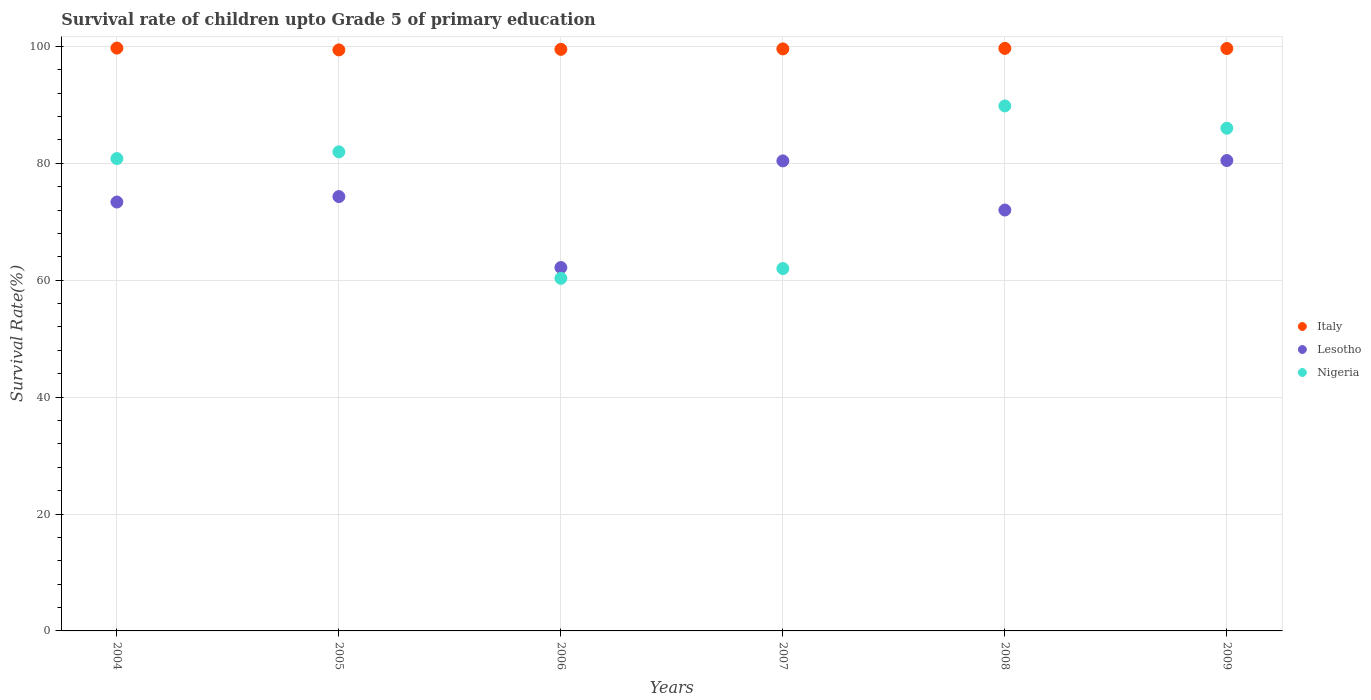Is the number of dotlines equal to the number of legend labels?
Your answer should be compact. Yes. What is the survival rate of children in Nigeria in 2008?
Your response must be concise. 89.82. Across all years, what is the maximum survival rate of children in Italy?
Offer a very short reply. 99.71. Across all years, what is the minimum survival rate of children in Lesotho?
Your answer should be compact. 62.17. In which year was the survival rate of children in Nigeria maximum?
Offer a terse response. 2008. What is the total survival rate of children in Nigeria in the graph?
Your response must be concise. 460.9. What is the difference between the survival rate of children in Italy in 2006 and that in 2009?
Your answer should be compact. -0.14. What is the difference between the survival rate of children in Italy in 2006 and the survival rate of children in Lesotho in 2009?
Your answer should be very brief. 19.02. What is the average survival rate of children in Italy per year?
Offer a very short reply. 99.58. In the year 2005, what is the difference between the survival rate of children in Nigeria and survival rate of children in Lesotho?
Your answer should be compact. 7.65. What is the ratio of the survival rate of children in Lesotho in 2007 to that in 2008?
Your answer should be compact. 1.12. What is the difference between the highest and the second highest survival rate of children in Italy?
Your answer should be very brief. 0.05. What is the difference between the highest and the lowest survival rate of children in Lesotho?
Provide a short and direct response. 18.31. Is the sum of the survival rate of children in Lesotho in 2007 and 2009 greater than the maximum survival rate of children in Nigeria across all years?
Make the answer very short. Yes. Is it the case that in every year, the sum of the survival rate of children in Lesotho and survival rate of children in Nigeria  is greater than the survival rate of children in Italy?
Give a very brief answer. Yes. Is the survival rate of children in Lesotho strictly greater than the survival rate of children in Nigeria over the years?
Your response must be concise. No. Is the survival rate of children in Italy strictly less than the survival rate of children in Lesotho over the years?
Your answer should be compact. No. What is the difference between two consecutive major ticks on the Y-axis?
Make the answer very short. 20. What is the title of the graph?
Give a very brief answer. Survival rate of children upto Grade 5 of primary education. What is the label or title of the X-axis?
Provide a short and direct response. Years. What is the label or title of the Y-axis?
Make the answer very short. Survival Rate(%). What is the Survival Rate(%) of Italy in 2004?
Make the answer very short. 99.71. What is the Survival Rate(%) of Lesotho in 2004?
Give a very brief answer. 73.37. What is the Survival Rate(%) of Nigeria in 2004?
Make the answer very short. 80.81. What is the Survival Rate(%) of Italy in 2005?
Your answer should be compact. 99.4. What is the Survival Rate(%) in Lesotho in 2005?
Your response must be concise. 74.31. What is the Survival Rate(%) of Nigeria in 2005?
Give a very brief answer. 81.96. What is the Survival Rate(%) in Italy in 2006?
Ensure brevity in your answer.  99.5. What is the Survival Rate(%) of Lesotho in 2006?
Provide a short and direct response. 62.17. What is the Survival Rate(%) of Nigeria in 2006?
Your response must be concise. 60.32. What is the Survival Rate(%) of Italy in 2007?
Make the answer very short. 99.57. What is the Survival Rate(%) in Lesotho in 2007?
Give a very brief answer. 80.41. What is the Survival Rate(%) of Nigeria in 2007?
Keep it short and to the point. 61.99. What is the Survival Rate(%) in Italy in 2008?
Give a very brief answer. 99.66. What is the Survival Rate(%) in Lesotho in 2008?
Offer a terse response. 72. What is the Survival Rate(%) in Nigeria in 2008?
Offer a terse response. 89.82. What is the Survival Rate(%) of Italy in 2009?
Give a very brief answer. 99.64. What is the Survival Rate(%) of Lesotho in 2009?
Give a very brief answer. 80.48. What is the Survival Rate(%) in Nigeria in 2009?
Ensure brevity in your answer.  86. Across all years, what is the maximum Survival Rate(%) of Italy?
Ensure brevity in your answer.  99.71. Across all years, what is the maximum Survival Rate(%) in Lesotho?
Your answer should be compact. 80.48. Across all years, what is the maximum Survival Rate(%) in Nigeria?
Offer a terse response. 89.82. Across all years, what is the minimum Survival Rate(%) in Italy?
Keep it short and to the point. 99.4. Across all years, what is the minimum Survival Rate(%) of Lesotho?
Make the answer very short. 62.17. Across all years, what is the minimum Survival Rate(%) in Nigeria?
Provide a short and direct response. 60.32. What is the total Survival Rate(%) of Italy in the graph?
Provide a short and direct response. 597.49. What is the total Survival Rate(%) in Lesotho in the graph?
Give a very brief answer. 442.74. What is the total Survival Rate(%) in Nigeria in the graph?
Ensure brevity in your answer.  460.9. What is the difference between the Survival Rate(%) in Italy in 2004 and that in 2005?
Keep it short and to the point. 0.31. What is the difference between the Survival Rate(%) of Lesotho in 2004 and that in 2005?
Keep it short and to the point. -0.94. What is the difference between the Survival Rate(%) in Nigeria in 2004 and that in 2005?
Offer a very short reply. -1.15. What is the difference between the Survival Rate(%) of Italy in 2004 and that in 2006?
Provide a succinct answer. 0.21. What is the difference between the Survival Rate(%) of Lesotho in 2004 and that in 2006?
Provide a short and direct response. 11.21. What is the difference between the Survival Rate(%) in Nigeria in 2004 and that in 2006?
Give a very brief answer. 20.49. What is the difference between the Survival Rate(%) of Italy in 2004 and that in 2007?
Keep it short and to the point. 0.14. What is the difference between the Survival Rate(%) in Lesotho in 2004 and that in 2007?
Ensure brevity in your answer.  -7.04. What is the difference between the Survival Rate(%) of Nigeria in 2004 and that in 2007?
Offer a very short reply. 18.82. What is the difference between the Survival Rate(%) in Italy in 2004 and that in 2008?
Your response must be concise. 0.05. What is the difference between the Survival Rate(%) in Lesotho in 2004 and that in 2008?
Your response must be concise. 1.37. What is the difference between the Survival Rate(%) in Nigeria in 2004 and that in 2008?
Provide a succinct answer. -9. What is the difference between the Survival Rate(%) in Italy in 2004 and that in 2009?
Offer a terse response. 0.07. What is the difference between the Survival Rate(%) of Lesotho in 2004 and that in 2009?
Your answer should be compact. -7.1. What is the difference between the Survival Rate(%) in Nigeria in 2004 and that in 2009?
Make the answer very short. -5.19. What is the difference between the Survival Rate(%) in Italy in 2005 and that in 2006?
Provide a short and direct response. -0.1. What is the difference between the Survival Rate(%) in Lesotho in 2005 and that in 2006?
Provide a short and direct response. 12.14. What is the difference between the Survival Rate(%) in Nigeria in 2005 and that in 2006?
Offer a very short reply. 21.64. What is the difference between the Survival Rate(%) of Italy in 2005 and that in 2007?
Make the answer very short. -0.17. What is the difference between the Survival Rate(%) of Lesotho in 2005 and that in 2007?
Provide a succinct answer. -6.1. What is the difference between the Survival Rate(%) in Nigeria in 2005 and that in 2007?
Provide a short and direct response. 19.97. What is the difference between the Survival Rate(%) of Italy in 2005 and that in 2008?
Offer a very short reply. -0.26. What is the difference between the Survival Rate(%) of Lesotho in 2005 and that in 2008?
Offer a very short reply. 2.31. What is the difference between the Survival Rate(%) of Nigeria in 2005 and that in 2008?
Make the answer very short. -7.85. What is the difference between the Survival Rate(%) of Italy in 2005 and that in 2009?
Provide a short and direct response. -0.24. What is the difference between the Survival Rate(%) of Lesotho in 2005 and that in 2009?
Give a very brief answer. -6.17. What is the difference between the Survival Rate(%) in Nigeria in 2005 and that in 2009?
Give a very brief answer. -4.04. What is the difference between the Survival Rate(%) in Italy in 2006 and that in 2007?
Ensure brevity in your answer.  -0.08. What is the difference between the Survival Rate(%) in Lesotho in 2006 and that in 2007?
Ensure brevity in your answer.  -18.24. What is the difference between the Survival Rate(%) of Nigeria in 2006 and that in 2007?
Offer a very short reply. -1.67. What is the difference between the Survival Rate(%) in Italy in 2006 and that in 2008?
Offer a very short reply. -0.16. What is the difference between the Survival Rate(%) of Lesotho in 2006 and that in 2008?
Give a very brief answer. -9.84. What is the difference between the Survival Rate(%) of Nigeria in 2006 and that in 2008?
Keep it short and to the point. -29.49. What is the difference between the Survival Rate(%) in Italy in 2006 and that in 2009?
Provide a succinct answer. -0.14. What is the difference between the Survival Rate(%) in Lesotho in 2006 and that in 2009?
Give a very brief answer. -18.31. What is the difference between the Survival Rate(%) in Nigeria in 2006 and that in 2009?
Give a very brief answer. -25.68. What is the difference between the Survival Rate(%) of Italy in 2007 and that in 2008?
Your answer should be compact. -0.09. What is the difference between the Survival Rate(%) in Lesotho in 2007 and that in 2008?
Provide a short and direct response. 8.41. What is the difference between the Survival Rate(%) in Nigeria in 2007 and that in 2008?
Provide a succinct answer. -27.82. What is the difference between the Survival Rate(%) in Italy in 2007 and that in 2009?
Your response must be concise. -0.07. What is the difference between the Survival Rate(%) in Lesotho in 2007 and that in 2009?
Your answer should be very brief. -0.07. What is the difference between the Survival Rate(%) of Nigeria in 2007 and that in 2009?
Provide a succinct answer. -24.01. What is the difference between the Survival Rate(%) in Italy in 2008 and that in 2009?
Your response must be concise. 0.02. What is the difference between the Survival Rate(%) in Lesotho in 2008 and that in 2009?
Provide a succinct answer. -8.47. What is the difference between the Survival Rate(%) in Nigeria in 2008 and that in 2009?
Make the answer very short. 3.81. What is the difference between the Survival Rate(%) of Italy in 2004 and the Survival Rate(%) of Lesotho in 2005?
Offer a very short reply. 25.4. What is the difference between the Survival Rate(%) of Italy in 2004 and the Survival Rate(%) of Nigeria in 2005?
Make the answer very short. 17.75. What is the difference between the Survival Rate(%) of Lesotho in 2004 and the Survival Rate(%) of Nigeria in 2005?
Offer a very short reply. -8.59. What is the difference between the Survival Rate(%) in Italy in 2004 and the Survival Rate(%) in Lesotho in 2006?
Provide a short and direct response. 37.54. What is the difference between the Survival Rate(%) of Italy in 2004 and the Survival Rate(%) of Nigeria in 2006?
Keep it short and to the point. 39.39. What is the difference between the Survival Rate(%) in Lesotho in 2004 and the Survival Rate(%) in Nigeria in 2006?
Provide a short and direct response. 13.05. What is the difference between the Survival Rate(%) in Italy in 2004 and the Survival Rate(%) in Lesotho in 2007?
Make the answer very short. 19.3. What is the difference between the Survival Rate(%) in Italy in 2004 and the Survival Rate(%) in Nigeria in 2007?
Provide a short and direct response. 37.72. What is the difference between the Survival Rate(%) of Lesotho in 2004 and the Survival Rate(%) of Nigeria in 2007?
Offer a terse response. 11.38. What is the difference between the Survival Rate(%) in Italy in 2004 and the Survival Rate(%) in Lesotho in 2008?
Your answer should be very brief. 27.71. What is the difference between the Survival Rate(%) of Italy in 2004 and the Survival Rate(%) of Nigeria in 2008?
Your answer should be compact. 9.9. What is the difference between the Survival Rate(%) of Lesotho in 2004 and the Survival Rate(%) of Nigeria in 2008?
Ensure brevity in your answer.  -16.44. What is the difference between the Survival Rate(%) in Italy in 2004 and the Survival Rate(%) in Lesotho in 2009?
Keep it short and to the point. 19.24. What is the difference between the Survival Rate(%) in Italy in 2004 and the Survival Rate(%) in Nigeria in 2009?
Your response must be concise. 13.71. What is the difference between the Survival Rate(%) in Lesotho in 2004 and the Survival Rate(%) in Nigeria in 2009?
Ensure brevity in your answer.  -12.63. What is the difference between the Survival Rate(%) in Italy in 2005 and the Survival Rate(%) in Lesotho in 2006?
Keep it short and to the point. 37.23. What is the difference between the Survival Rate(%) in Italy in 2005 and the Survival Rate(%) in Nigeria in 2006?
Offer a terse response. 39.08. What is the difference between the Survival Rate(%) of Lesotho in 2005 and the Survival Rate(%) of Nigeria in 2006?
Provide a succinct answer. 13.99. What is the difference between the Survival Rate(%) of Italy in 2005 and the Survival Rate(%) of Lesotho in 2007?
Provide a short and direct response. 18.99. What is the difference between the Survival Rate(%) in Italy in 2005 and the Survival Rate(%) in Nigeria in 2007?
Provide a succinct answer. 37.41. What is the difference between the Survival Rate(%) in Lesotho in 2005 and the Survival Rate(%) in Nigeria in 2007?
Your answer should be compact. 12.32. What is the difference between the Survival Rate(%) of Italy in 2005 and the Survival Rate(%) of Lesotho in 2008?
Your answer should be very brief. 27.4. What is the difference between the Survival Rate(%) of Italy in 2005 and the Survival Rate(%) of Nigeria in 2008?
Your answer should be compact. 9.59. What is the difference between the Survival Rate(%) of Lesotho in 2005 and the Survival Rate(%) of Nigeria in 2008?
Your response must be concise. -15.51. What is the difference between the Survival Rate(%) in Italy in 2005 and the Survival Rate(%) in Lesotho in 2009?
Keep it short and to the point. 18.92. What is the difference between the Survival Rate(%) of Italy in 2005 and the Survival Rate(%) of Nigeria in 2009?
Ensure brevity in your answer.  13.4. What is the difference between the Survival Rate(%) in Lesotho in 2005 and the Survival Rate(%) in Nigeria in 2009?
Offer a terse response. -11.69. What is the difference between the Survival Rate(%) of Italy in 2006 and the Survival Rate(%) of Lesotho in 2007?
Offer a very short reply. 19.09. What is the difference between the Survival Rate(%) of Italy in 2006 and the Survival Rate(%) of Nigeria in 2007?
Keep it short and to the point. 37.51. What is the difference between the Survival Rate(%) of Lesotho in 2006 and the Survival Rate(%) of Nigeria in 2007?
Give a very brief answer. 0.18. What is the difference between the Survival Rate(%) in Italy in 2006 and the Survival Rate(%) in Lesotho in 2008?
Your answer should be very brief. 27.49. What is the difference between the Survival Rate(%) in Italy in 2006 and the Survival Rate(%) in Nigeria in 2008?
Offer a terse response. 9.68. What is the difference between the Survival Rate(%) of Lesotho in 2006 and the Survival Rate(%) of Nigeria in 2008?
Offer a very short reply. -27.65. What is the difference between the Survival Rate(%) in Italy in 2006 and the Survival Rate(%) in Lesotho in 2009?
Make the answer very short. 19.02. What is the difference between the Survival Rate(%) in Italy in 2006 and the Survival Rate(%) in Nigeria in 2009?
Make the answer very short. 13.5. What is the difference between the Survival Rate(%) of Lesotho in 2006 and the Survival Rate(%) of Nigeria in 2009?
Give a very brief answer. -23.83. What is the difference between the Survival Rate(%) of Italy in 2007 and the Survival Rate(%) of Lesotho in 2008?
Ensure brevity in your answer.  27.57. What is the difference between the Survival Rate(%) of Italy in 2007 and the Survival Rate(%) of Nigeria in 2008?
Your response must be concise. 9.76. What is the difference between the Survival Rate(%) in Lesotho in 2007 and the Survival Rate(%) in Nigeria in 2008?
Provide a succinct answer. -9.4. What is the difference between the Survival Rate(%) in Italy in 2007 and the Survival Rate(%) in Lesotho in 2009?
Provide a succinct answer. 19.1. What is the difference between the Survival Rate(%) in Italy in 2007 and the Survival Rate(%) in Nigeria in 2009?
Your answer should be very brief. 13.57. What is the difference between the Survival Rate(%) of Lesotho in 2007 and the Survival Rate(%) of Nigeria in 2009?
Your response must be concise. -5.59. What is the difference between the Survival Rate(%) in Italy in 2008 and the Survival Rate(%) in Lesotho in 2009?
Keep it short and to the point. 19.18. What is the difference between the Survival Rate(%) in Italy in 2008 and the Survival Rate(%) in Nigeria in 2009?
Your answer should be very brief. 13.66. What is the difference between the Survival Rate(%) of Lesotho in 2008 and the Survival Rate(%) of Nigeria in 2009?
Make the answer very short. -14. What is the average Survival Rate(%) in Italy per year?
Offer a very short reply. 99.58. What is the average Survival Rate(%) of Lesotho per year?
Provide a short and direct response. 73.79. What is the average Survival Rate(%) of Nigeria per year?
Your response must be concise. 76.82. In the year 2004, what is the difference between the Survival Rate(%) in Italy and Survival Rate(%) in Lesotho?
Keep it short and to the point. 26.34. In the year 2004, what is the difference between the Survival Rate(%) in Italy and Survival Rate(%) in Nigeria?
Offer a very short reply. 18.9. In the year 2004, what is the difference between the Survival Rate(%) of Lesotho and Survival Rate(%) of Nigeria?
Give a very brief answer. -7.44. In the year 2005, what is the difference between the Survival Rate(%) in Italy and Survival Rate(%) in Lesotho?
Ensure brevity in your answer.  25.09. In the year 2005, what is the difference between the Survival Rate(%) in Italy and Survival Rate(%) in Nigeria?
Offer a terse response. 17.44. In the year 2005, what is the difference between the Survival Rate(%) in Lesotho and Survival Rate(%) in Nigeria?
Give a very brief answer. -7.65. In the year 2006, what is the difference between the Survival Rate(%) in Italy and Survival Rate(%) in Lesotho?
Make the answer very short. 37.33. In the year 2006, what is the difference between the Survival Rate(%) in Italy and Survival Rate(%) in Nigeria?
Provide a succinct answer. 39.18. In the year 2006, what is the difference between the Survival Rate(%) in Lesotho and Survival Rate(%) in Nigeria?
Provide a short and direct response. 1.85. In the year 2007, what is the difference between the Survival Rate(%) of Italy and Survival Rate(%) of Lesotho?
Your answer should be compact. 19.16. In the year 2007, what is the difference between the Survival Rate(%) of Italy and Survival Rate(%) of Nigeria?
Keep it short and to the point. 37.58. In the year 2007, what is the difference between the Survival Rate(%) of Lesotho and Survival Rate(%) of Nigeria?
Offer a very short reply. 18.42. In the year 2008, what is the difference between the Survival Rate(%) in Italy and Survival Rate(%) in Lesotho?
Offer a terse response. 27.66. In the year 2008, what is the difference between the Survival Rate(%) of Italy and Survival Rate(%) of Nigeria?
Ensure brevity in your answer.  9.85. In the year 2008, what is the difference between the Survival Rate(%) of Lesotho and Survival Rate(%) of Nigeria?
Provide a succinct answer. -17.81. In the year 2009, what is the difference between the Survival Rate(%) in Italy and Survival Rate(%) in Lesotho?
Provide a succinct answer. 19.17. In the year 2009, what is the difference between the Survival Rate(%) of Italy and Survival Rate(%) of Nigeria?
Your response must be concise. 13.64. In the year 2009, what is the difference between the Survival Rate(%) of Lesotho and Survival Rate(%) of Nigeria?
Ensure brevity in your answer.  -5.53. What is the ratio of the Survival Rate(%) in Italy in 2004 to that in 2005?
Your answer should be compact. 1. What is the ratio of the Survival Rate(%) in Lesotho in 2004 to that in 2005?
Give a very brief answer. 0.99. What is the ratio of the Survival Rate(%) in Nigeria in 2004 to that in 2005?
Your response must be concise. 0.99. What is the ratio of the Survival Rate(%) in Italy in 2004 to that in 2006?
Your response must be concise. 1. What is the ratio of the Survival Rate(%) in Lesotho in 2004 to that in 2006?
Provide a succinct answer. 1.18. What is the ratio of the Survival Rate(%) in Nigeria in 2004 to that in 2006?
Provide a succinct answer. 1.34. What is the ratio of the Survival Rate(%) in Lesotho in 2004 to that in 2007?
Offer a very short reply. 0.91. What is the ratio of the Survival Rate(%) in Nigeria in 2004 to that in 2007?
Give a very brief answer. 1.3. What is the ratio of the Survival Rate(%) in Nigeria in 2004 to that in 2008?
Offer a terse response. 0.9. What is the ratio of the Survival Rate(%) in Lesotho in 2004 to that in 2009?
Offer a terse response. 0.91. What is the ratio of the Survival Rate(%) in Nigeria in 2004 to that in 2009?
Provide a short and direct response. 0.94. What is the ratio of the Survival Rate(%) of Italy in 2005 to that in 2006?
Offer a terse response. 1. What is the ratio of the Survival Rate(%) in Lesotho in 2005 to that in 2006?
Offer a very short reply. 1.2. What is the ratio of the Survival Rate(%) of Nigeria in 2005 to that in 2006?
Give a very brief answer. 1.36. What is the ratio of the Survival Rate(%) of Lesotho in 2005 to that in 2007?
Provide a short and direct response. 0.92. What is the ratio of the Survival Rate(%) in Nigeria in 2005 to that in 2007?
Your answer should be compact. 1.32. What is the ratio of the Survival Rate(%) of Lesotho in 2005 to that in 2008?
Your answer should be compact. 1.03. What is the ratio of the Survival Rate(%) in Nigeria in 2005 to that in 2008?
Your answer should be very brief. 0.91. What is the ratio of the Survival Rate(%) in Lesotho in 2005 to that in 2009?
Your answer should be very brief. 0.92. What is the ratio of the Survival Rate(%) of Nigeria in 2005 to that in 2009?
Make the answer very short. 0.95. What is the ratio of the Survival Rate(%) in Italy in 2006 to that in 2007?
Offer a very short reply. 1. What is the ratio of the Survival Rate(%) of Lesotho in 2006 to that in 2007?
Ensure brevity in your answer.  0.77. What is the ratio of the Survival Rate(%) in Nigeria in 2006 to that in 2007?
Offer a terse response. 0.97. What is the ratio of the Survival Rate(%) in Lesotho in 2006 to that in 2008?
Ensure brevity in your answer.  0.86. What is the ratio of the Survival Rate(%) of Nigeria in 2006 to that in 2008?
Your response must be concise. 0.67. What is the ratio of the Survival Rate(%) of Italy in 2006 to that in 2009?
Provide a succinct answer. 1. What is the ratio of the Survival Rate(%) of Lesotho in 2006 to that in 2009?
Ensure brevity in your answer.  0.77. What is the ratio of the Survival Rate(%) of Nigeria in 2006 to that in 2009?
Offer a very short reply. 0.7. What is the ratio of the Survival Rate(%) in Italy in 2007 to that in 2008?
Give a very brief answer. 1. What is the ratio of the Survival Rate(%) in Lesotho in 2007 to that in 2008?
Offer a very short reply. 1.12. What is the ratio of the Survival Rate(%) in Nigeria in 2007 to that in 2008?
Your answer should be compact. 0.69. What is the ratio of the Survival Rate(%) in Italy in 2007 to that in 2009?
Offer a terse response. 1. What is the ratio of the Survival Rate(%) in Nigeria in 2007 to that in 2009?
Give a very brief answer. 0.72. What is the ratio of the Survival Rate(%) in Italy in 2008 to that in 2009?
Your answer should be very brief. 1. What is the ratio of the Survival Rate(%) in Lesotho in 2008 to that in 2009?
Provide a succinct answer. 0.89. What is the ratio of the Survival Rate(%) in Nigeria in 2008 to that in 2009?
Make the answer very short. 1.04. What is the difference between the highest and the second highest Survival Rate(%) of Italy?
Your answer should be very brief. 0.05. What is the difference between the highest and the second highest Survival Rate(%) of Lesotho?
Your answer should be compact. 0.07. What is the difference between the highest and the second highest Survival Rate(%) in Nigeria?
Give a very brief answer. 3.81. What is the difference between the highest and the lowest Survival Rate(%) of Italy?
Provide a short and direct response. 0.31. What is the difference between the highest and the lowest Survival Rate(%) in Lesotho?
Your answer should be very brief. 18.31. What is the difference between the highest and the lowest Survival Rate(%) of Nigeria?
Provide a succinct answer. 29.49. 